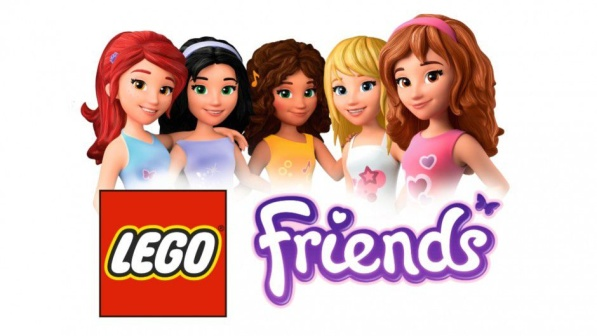Can you explain the target audience and the intended message of the Lego Friends product line as reflected in this image? Certainly! The Lego Friends series, as depicted in this image, is primarily aimed towards children who enjoy imaginative play and building. The product line focuses on the themes of friendship, individuality, and open-ended play. The diverse set of characters presented here, each with unique styles and personalities, encourages children to explore social constructs within a familiar Lego building context. Through the incorporation of relatable scenarios and vibrant settings, the line promotes inclusivity and creative expression. The intended message is one of camaraderie and unity, as the close-knit positioning of the characters alongside the friendly typography of the 'Friends' logo suggest a welcoming, community-oriented experience. 